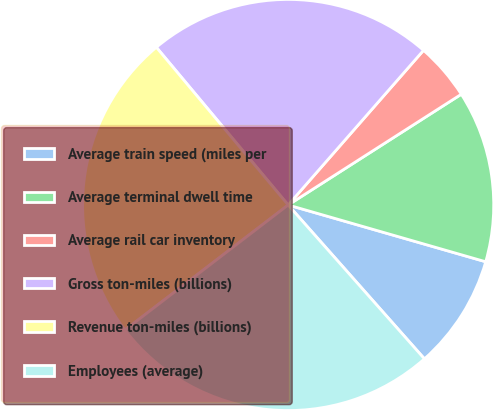Convert chart to OTSL. <chart><loc_0><loc_0><loc_500><loc_500><pie_chart><fcel>Average train speed (miles per<fcel>Average terminal dwell time<fcel>Average rail car inventory<fcel>Gross ton-miles (billions)<fcel>Revenue ton-miles (billions)<fcel>Employees (average)<nl><fcel>9.01%<fcel>13.51%<fcel>4.5%<fcel>22.52%<fcel>24.32%<fcel>26.13%<nl></chart> 